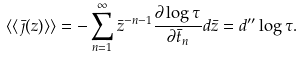Convert formula to latex. <formula><loc_0><loc_0><loc_500><loc_500>\langle \langle \bar { \jmath } ( z ) \rangle \rangle = - \sum _ { n = 1 } ^ { \infty } \bar { z } ^ { - n - 1 } \frac { \partial \log \tau } { \partial \bar { t } _ { n } } d \bar { z } = d ^ { \prime \prime } \log \tau .</formula> 